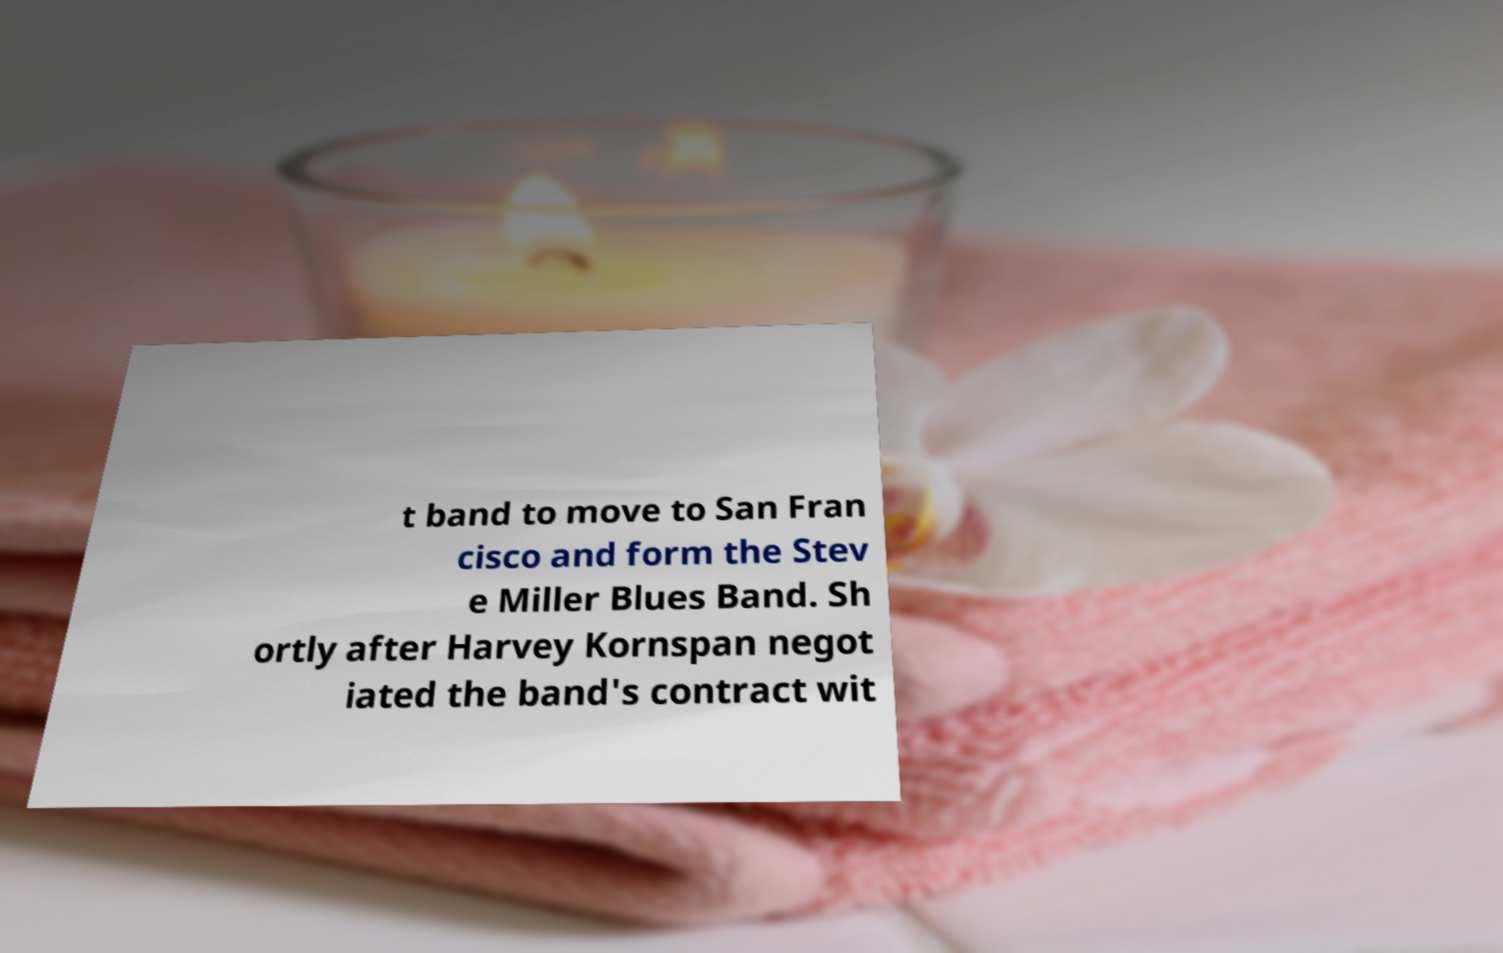Can you read and provide the text displayed in the image?This photo seems to have some interesting text. Can you extract and type it out for me? t band to move to San Fran cisco and form the Stev e Miller Blues Band. Sh ortly after Harvey Kornspan negot iated the band's contract wit 